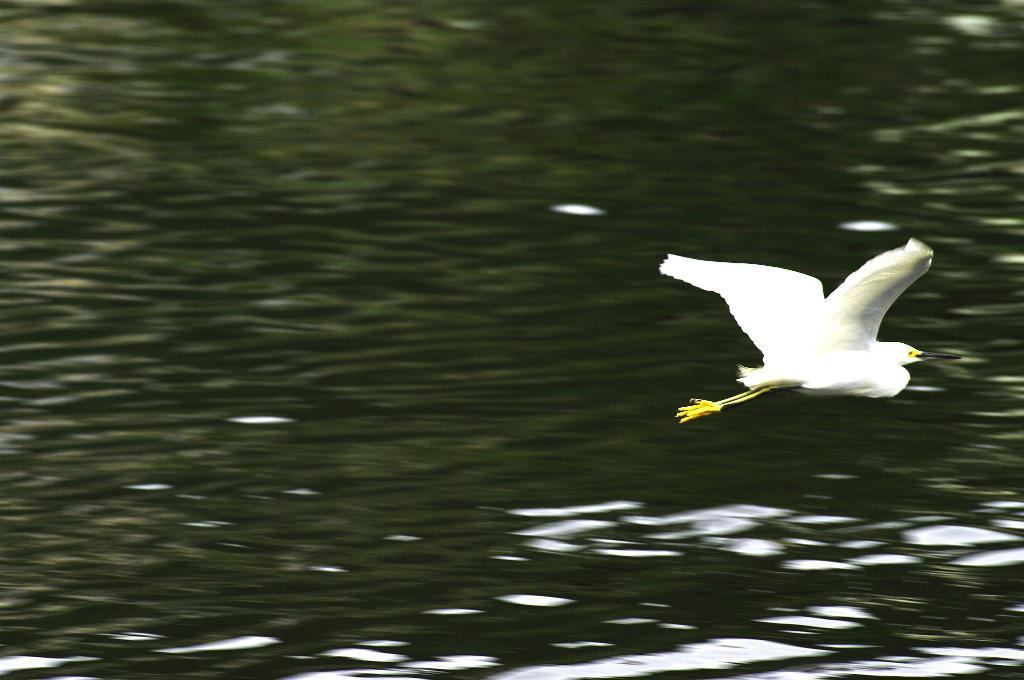What is present in the image? There is a bird in the image. What is the bird doing in the image? The bird is flying in the air. Can you describe the colors of the bird? The bird has white and yellow colors. What can be seen in the background of the image? There is water visible in the background of the image. What type of industry can be seen in the image? There is no industry present in the image; it features a bird flying over water. Can you tell me which shop the bird is visiting in the image? There is no shop present in the image, as it only shows a bird flying over water. 